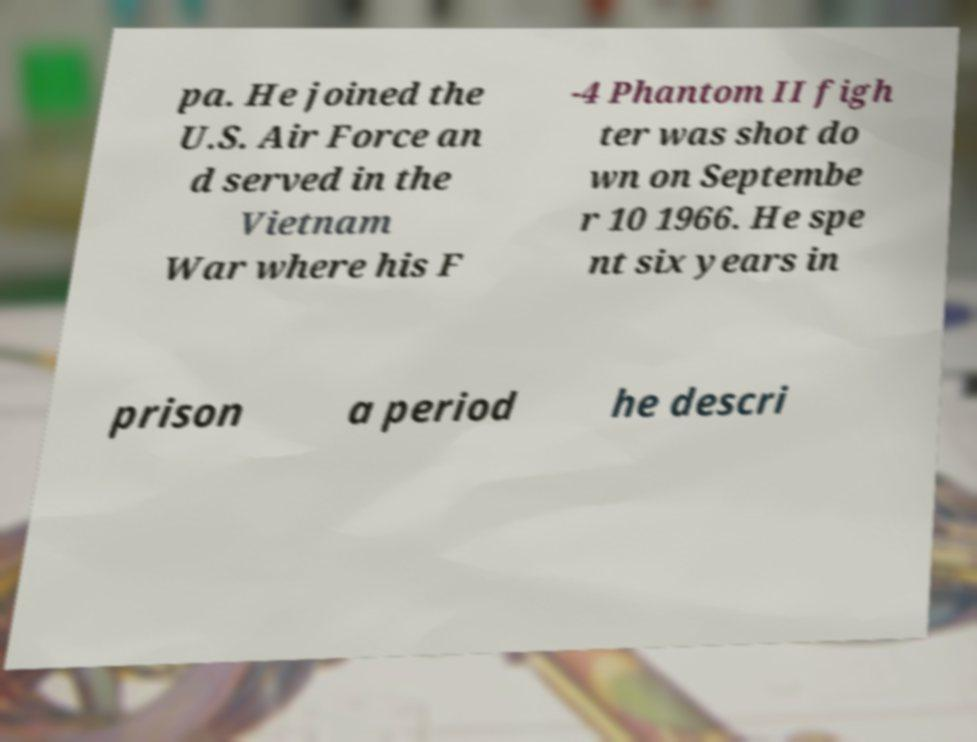Could you assist in decoding the text presented in this image and type it out clearly? pa. He joined the U.S. Air Force an d served in the Vietnam War where his F -4 Phantom II figh ter was shot do wn on Septembe r 10 1966. He spe nt six years in prison a period he descri 